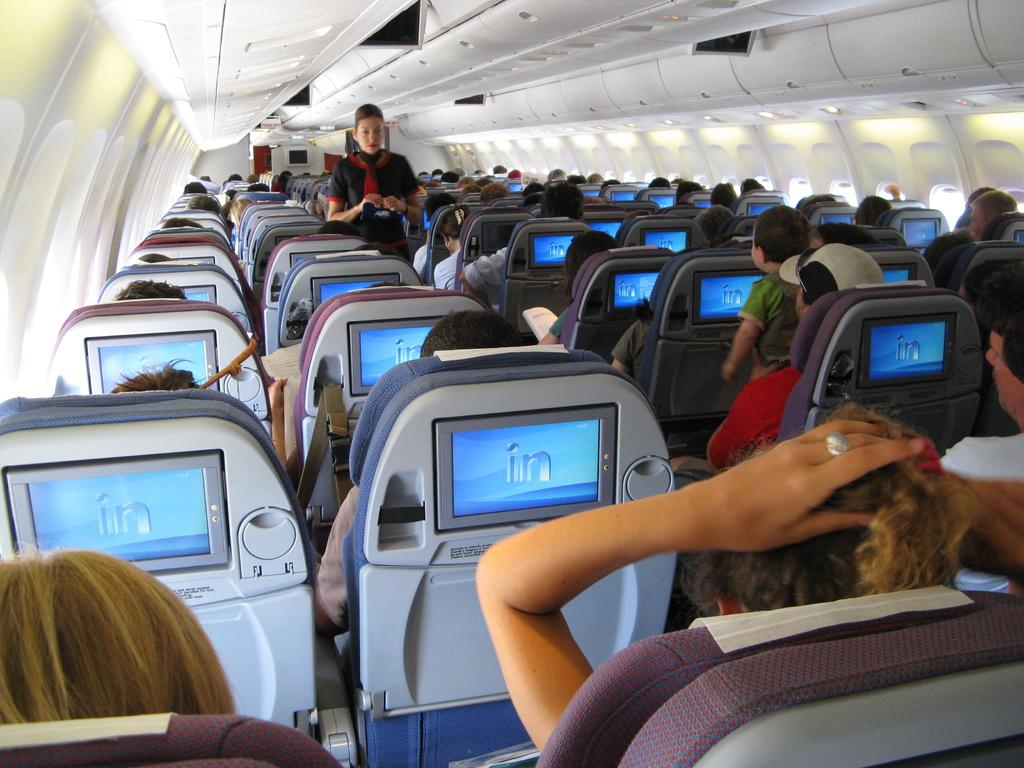What is the main subject of the picture? The main subject of the picture is an airplane. What can be seen inside the airplane? There are people sitting in the airplane. Who is present to assist the passengers in the airplane? There is an air hostess in the airplane. What type of chalk drawing can be seen on the airplane's wing? There is no chalk drawing present on the airplane's wing in the image. 